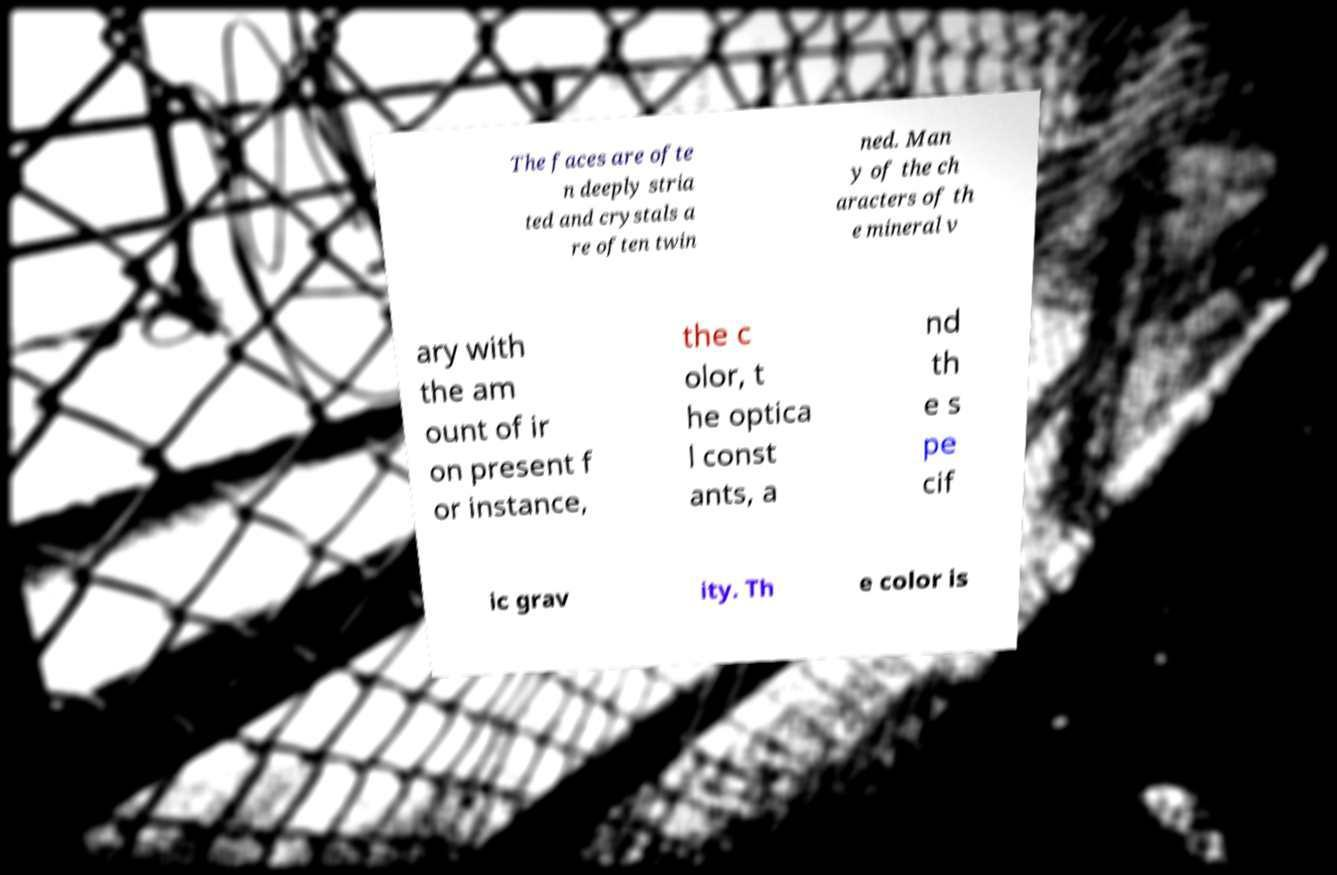What messages or text are displayed in this image? I need them in a readable, typed format. The faces are ofte n deeply stria ted and crystals a re often twin ned. Man y of the ch aracters of th e mineral v ary with the am ount of ir on present f or instance, the c olor, t he optica l const ants, a nd th e s pe cif ic grav ity. Th e color is 